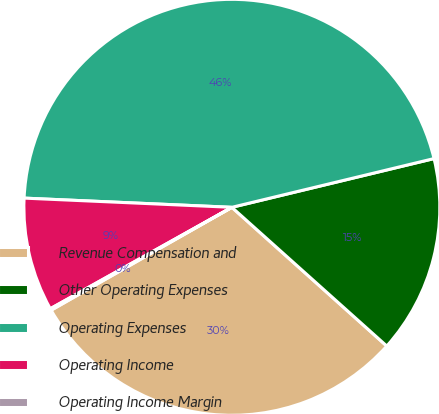<chart> <loc_0><loc_0><loc_500><loc_500><pie_chart><fcel>Revenue Compensation and<fcel>Other Operating Expenses<fcel>Operating Expenses<fcel>Operating Income<fcel>Operating Income Margin<nl><fcel>30.14%<fcel>15.39%<fcel>45.53%<fcel>8.81%<fcel>0.13%<nl></chart> 